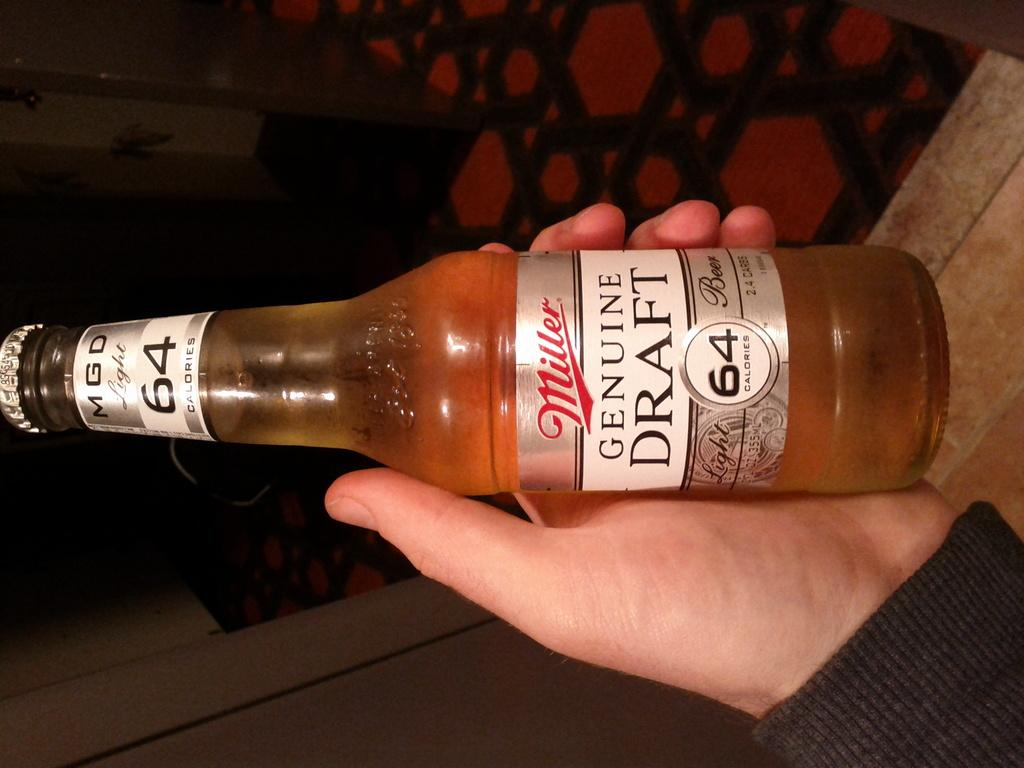<image>
Share a concise interpretation of the image provided. Person holding a Miller genuine draft beer with 64 calories. 